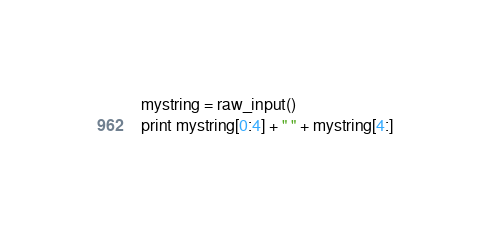Convert code to text. <code><loc_0><loc_0><loc_500><loc_500><_Python_>mystring = raw_input()
print mystring[0:4] + " " + mystring[4:]</code> 